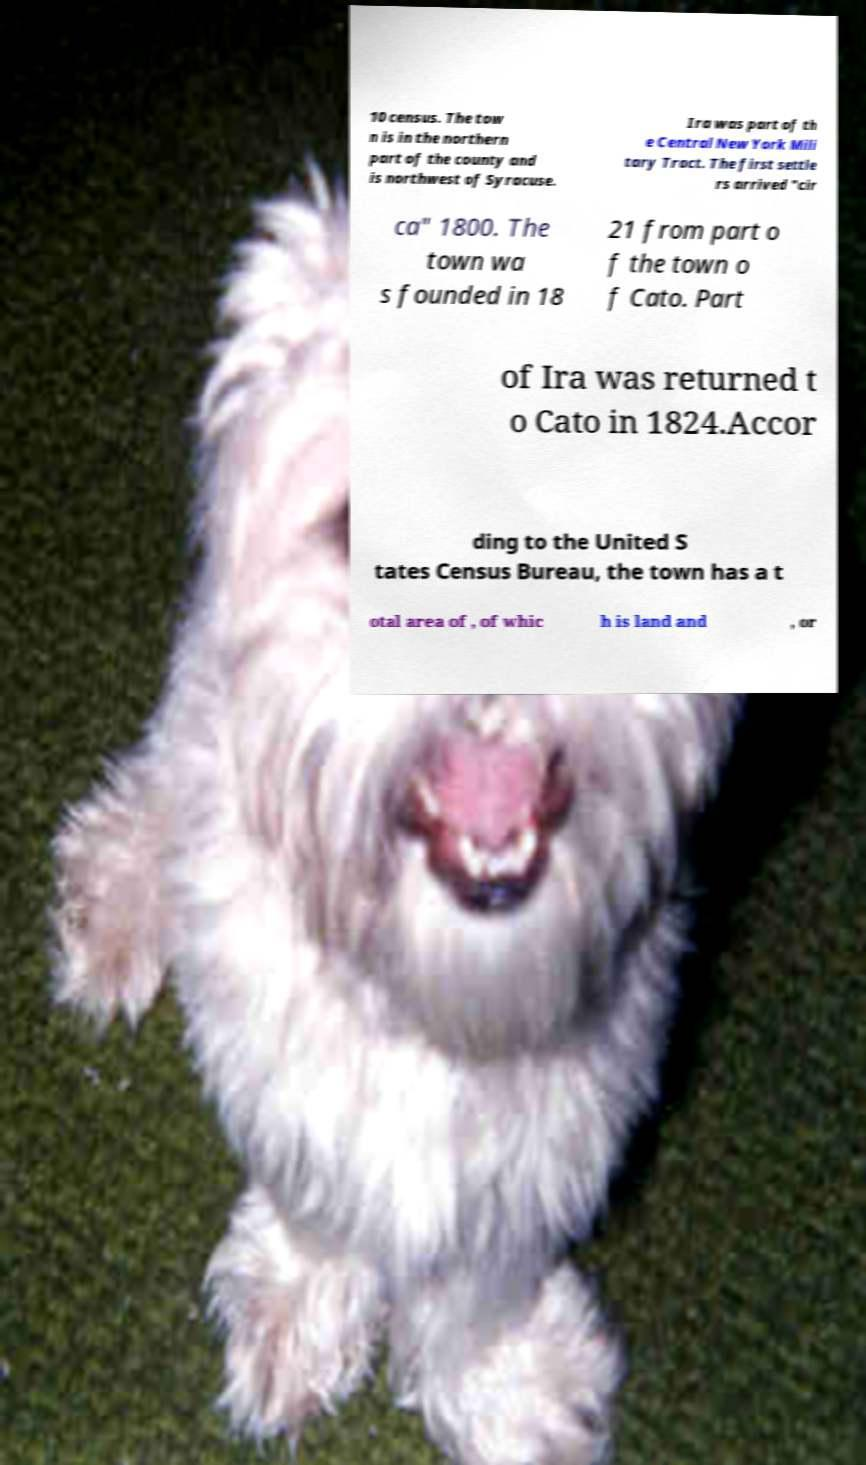Could you assist in decoding the text presented in this image and type it out clearly? 10 census. The tow n is in the northern part of the county and is northwest of Syracuse. Ira was part of th e Central New York Mili tary Tract. The first settle rs arrived "cir ca" 1800. The town wa s founded in 18 21 from part o f the town o f Cato. Part of Ira was returned t o Cato in 1824.Accor ding to the United S tates Census Bureau, the town has a t otal area of , of whic h is land and , or 